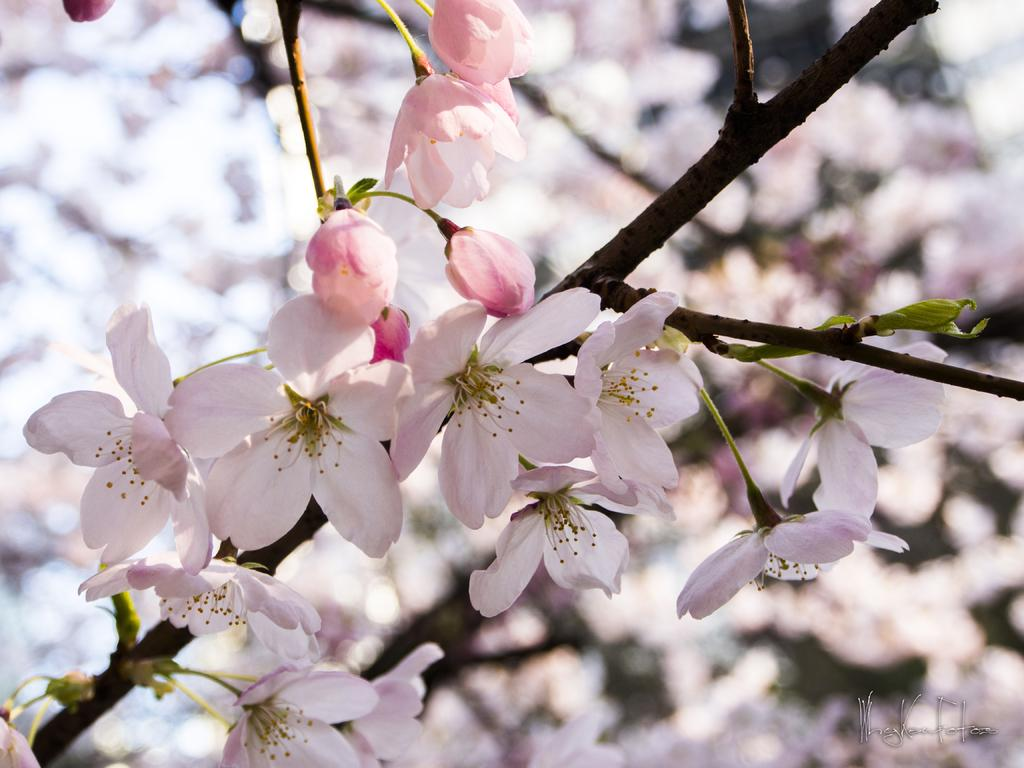What type of plants can be seen in the image? There are flowers and trees in the image. Can you describe the natural environment depicted in the image? The image features flowers and trees, which suggests a natural setting. What type of flag is visible in the image? There is no flag present in the image. What condition is the page in, and what is it written on? There is no page or writing present in the image. 